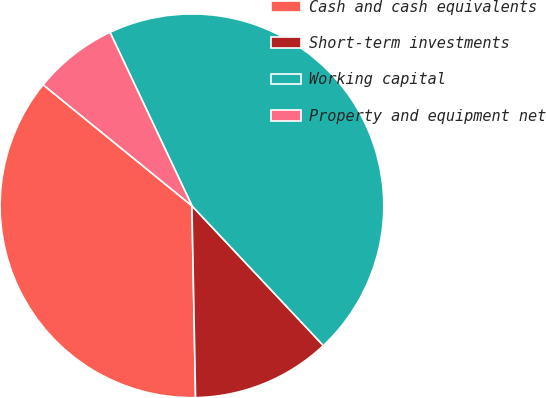Convert chart. <chart><loc_0><loc_0><loc_500><loc_500><pie_chart><fcel>Cash and cash equivalents<fcel>Short-term investments<fcel>Working capital<fcel>Property and equipment net<nl><fcel>36.17%<fcel>11.71%<fcel>45.01%<fcel>7.11%<nl></chart> 